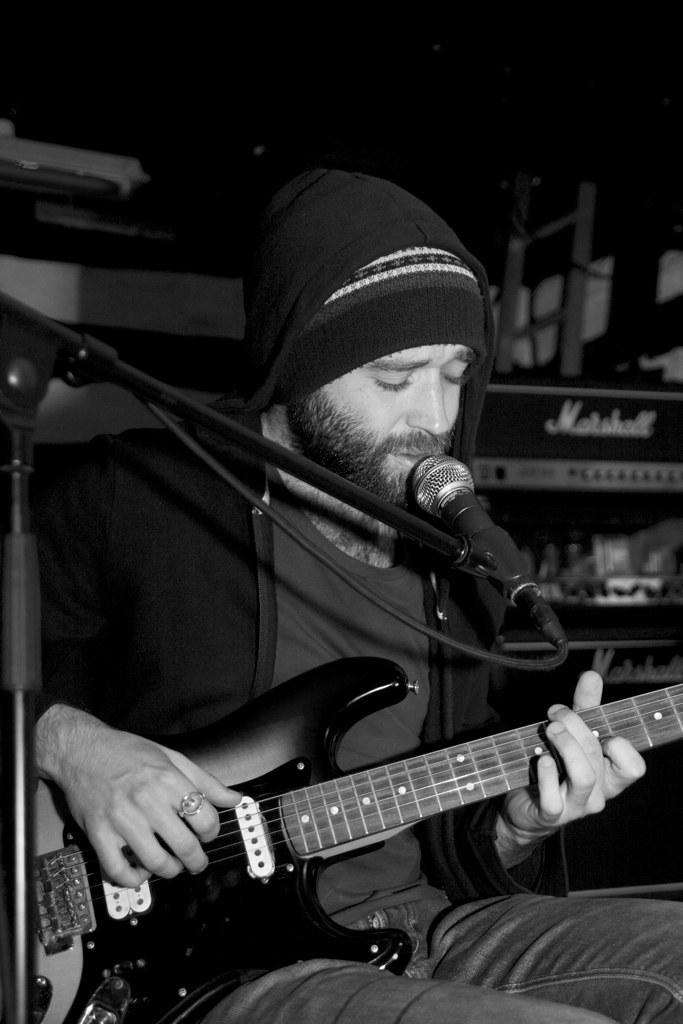What is the color scheme of the image? The image is black and white. What is the man in the image doing? The man is sitting, playing a guitar, and singing into a microphone. How is the microphone positioned in the image? The microphone is attached to a microphone stand. What is the value of the heart-shaped object on the guitar in the image? There is no heart-shaped object present on the guitar in the image. 